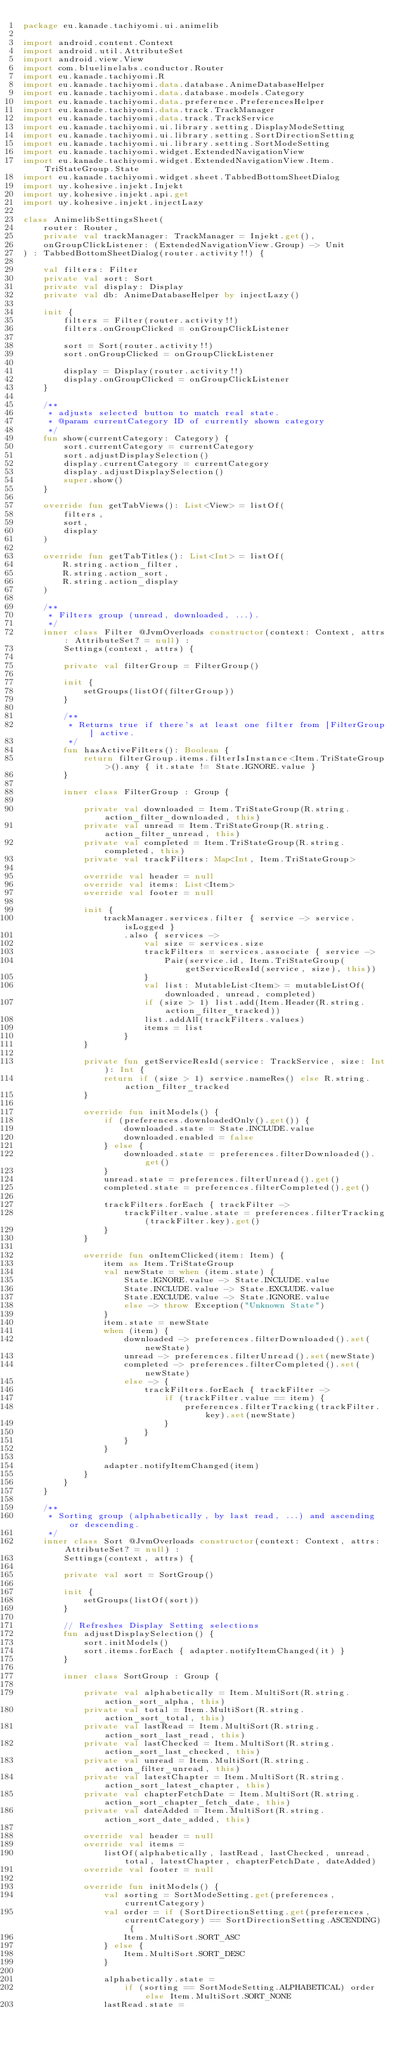<code> <loc_0><loc_0><loc_500><loc_500><_Kotlin_>package eu.kanade.tachiyomi.ui.animelib

import android.content.Context
import android.util.AttributeSet
import android.view.View
import com.bluelinelabs.conductor.Router
import eu.kanade.tachiyomi.R
import eu.kanade.tachiyomi.data.database.AnimeDatabaseHelper
import eu.kanade.tachiyomi.data.database.models.Category
import eu.kanade.tachiyomi.data.preference.PreferencesHelper
import eu.kanade.tachiyomi.data.track.TrackManager
import eu.kanade.tachiyomi.data.track.TrackService
import eu.kanade.tachiyomi.ui.library.setting.DisplayModeSetting
import eu.kanade.tachiyomi.ui.library.setting.SortDirectionSetting
import eu.kanade.tachiyomi.ui.library.setting.SortModeSetting
import eu.kanade.tachiyomi.widget.ExtendedNavigationView
import eu.kanade.tachiyomi.widget.ExtendedNavigationView.Item.TriStateGroup.State
import eu.kanade.tachiyomi.widget.sheet.TabbedBottomSheetDialog
import uy.kohesive.injekt.Injekt
import uy.kohesive.injekt.api.get
import uy.kohesive.injekt.injectLazy

class AnimelibSettingsSheet(
    router: Router,
    private val trackManager: TrackManager = Injekt.get(),
    onGroupClickListener: (ExtendedNavigationView.Group) -> Unit
) : TabbedBottomSheetDialog(router.activity!!) {

    val filters: Filter
    private val sort: Sort
    private val display: Display
    private val db: AnimeDatabaseHelper by injectLazy()

    init {
        filters = Filter(router.activity!!)
        filters.onGroupClicked = onGroupClickListener

        sort = Sort(router.activity!!)
        sort.onGroupClicked = onGroupClickListener

        display = Display(router.activity!!)
        display.onGroupClicked = onGroupClickListener
    }

    /**
     * adjusts selected button to match real state.
     * @param currentCategory ID of currently shown category
     */
    fun show(currentCategory: Category) {
        sort.currentCategory = currentCategory
        sort.adjustDisplaySelection()
        display.currentCategory = currentCategory
        display.adjustDisplaySelection()
        super.show()
    }

    override fun getTabViews(): List<View> = listOf(
        filters,
        sort,
        display
    )

    override fun getTabTitles(): List<Int> = listOf(
        R.string.action_filter,
        R.string.action_sort,
        R.string.action_display
    )

    /**
     * Filters group (unread, downloaded, ...).
     */
    inner class Filter @JvmOverloads constructor(context: Context, attrs: AttributeSet? = null) :
        Settings(context, attrs) {

        private val filterGroup = FilterGroup()

        init {
            setGroups(listOf(filterGroup))
        }

        /**
         * Returns true if there's at least one filter from [FilterGroup] active.
         */
        fun hasActiveFilters(): Boolean {
            return filterGroup.items.filterIsInstance<Item.TriStateGroup>().any { it.state != State.IGNORE.value }
        }

        inner class FilterGroup : Group {

            private val downloaded = Item.TriStateGroup(R.string.action_filter_downloaded, this)
            private val unread = Item.TriStateGroup(R.string.action_filter_unread, this)
            private val completed = Item.TriStateGroup(R.string.completed, this)
            private val trackFilters: Map<Int, Item.TriStateGroup>

            override val header = null
            override val items: List<Item>
            override val footer = null

            init {
                trackManager.services.filter { service -> service.isLogged }
                    .also { services ->
                        val size = services.size
                        trackFilters = services.associate { service ->
                            Pair(service.id, Item.TriStateGroup(getServiceResId(service, size), this))
                        }
                        val list: MutableList<Item> = mutableListOf(downloaded, unread, completed)
                        if (size > 1) list.add(Item.Header(R.string.action_filter_tracked))
                        list.addAll(trackFilters.values)
                        items = list
                    }
            }

            private fun getServiceResId(service: TrackService, size: Int): Int {
                return if (size > 1) service.nameRes() else R.string.action_filter_tracked
            }

            override fun initModels() {
                if (preferences.downloadedOnly().get()) {
                    downloaded.state = State.INCLUDE.value
                    downloaded.enabled = false
                } else {
                    downloaded.state = preferences.filterDownloaded().get()
                }
                unread.state = preferences.filterUnread().get()
                completed.state = preferences.filterCompleted().get()

                trackFilters.forEach { trackFilter ->
                    trackFilter.value.state = preferences.filterTracking(trackFilter.key).get()
                }
            }

            override fun onItemClicked(item: Item) {
                item as Item.TriStateGroup
                val newState = when (item.state) {
                    State.IGNORE.value -> State.INCLUDE.value
                    State.INCLUDE.value -> State.EXCLUDE.value
                    State.EXCLUDE.value -> State.IGNORE.value
                    else -> throw Exception("Unknown State")
                }
                item.state = newState
                when (item) {
                    downloaded -> preferences.filterDownloaded().set(newState)
                    unread -> preferences.filterUnread().set(newState)
                    completed -> preferences.filterCompleted().set(newState)
                    else -> {
                        trackFilters.forEach { trackFilter ->
                            if (trackFilter.value == item) {
                                preferences.filterTracking(trackFilter.key).set(newState)
                            }
                        }
                    }
                }

                adapter.notifyItemChanged(item)
            }
        }
    }

    /**
     * Sorting group (alphabetically, by last read, ...) and ascending or descending.
     */
    inner class Sort @JvmOverloads constructor(context: Context, attrs: AttributeSet? = null) :
        Settings(context, attrs) {

        private val sort = SortGroup()

        init {
            setGroups(listOf(sort))
        }

        // Refreshes Display Setting selections
        fun adjustDisplaySelection() {
            sort.initModels()
            sort.items.forEach { adapter.notifyItemChanged(it) }
        }

        inner class SortGroup : Group {

            private val alphabetically = Item.MultiSort(R.string.action_sort_alpha, this)
            private val total = Item.MultiSort(R.string.action_sort_total, this)
            private val lastRead = Item.MultiSort(R.string.action_sort_last_read, this)
            private val lastChecked = Item.MultiSort(R.string.action_sort_last_checked, this)
            private val unread = Item.MultiSort(R.string.action_filter_unread, this)
            private val latestChapter = Item.MultiSort(R.string.action_sort_latest_chapter, this)
            private val chapterFetchDate = Item.MultiSort(R.string.action_sort_chapter_fetch_date, this)
            private val dateAdded = Item.MultiSort(R.string.action_sort_date_added, this)

            override val header = null
            override val items =
                listOf(alphabetically, lastRead, lastChecked, unread, total, latestChapter, chapterFetchDate, dateAdded)
            override val footer = null

            override fun initModels() {
                val sorting = SortModeSetting.get(preferences, currentCategory)
                val order = if (SortDirectionSetting.get(preferences, currentCategory) == SortDirectionSetting.ASCENDING) {
                    Item.MultiSort.SORT_ASC
                } else {
                    Item.MultiSort.SORT_DESC
                }

                alphabetically.state =
                    if (sorting == SortModeSetting.ALPHABETICAL) order else Item.MultiSort.SORT_NONE
                lastRead.state =</code> 